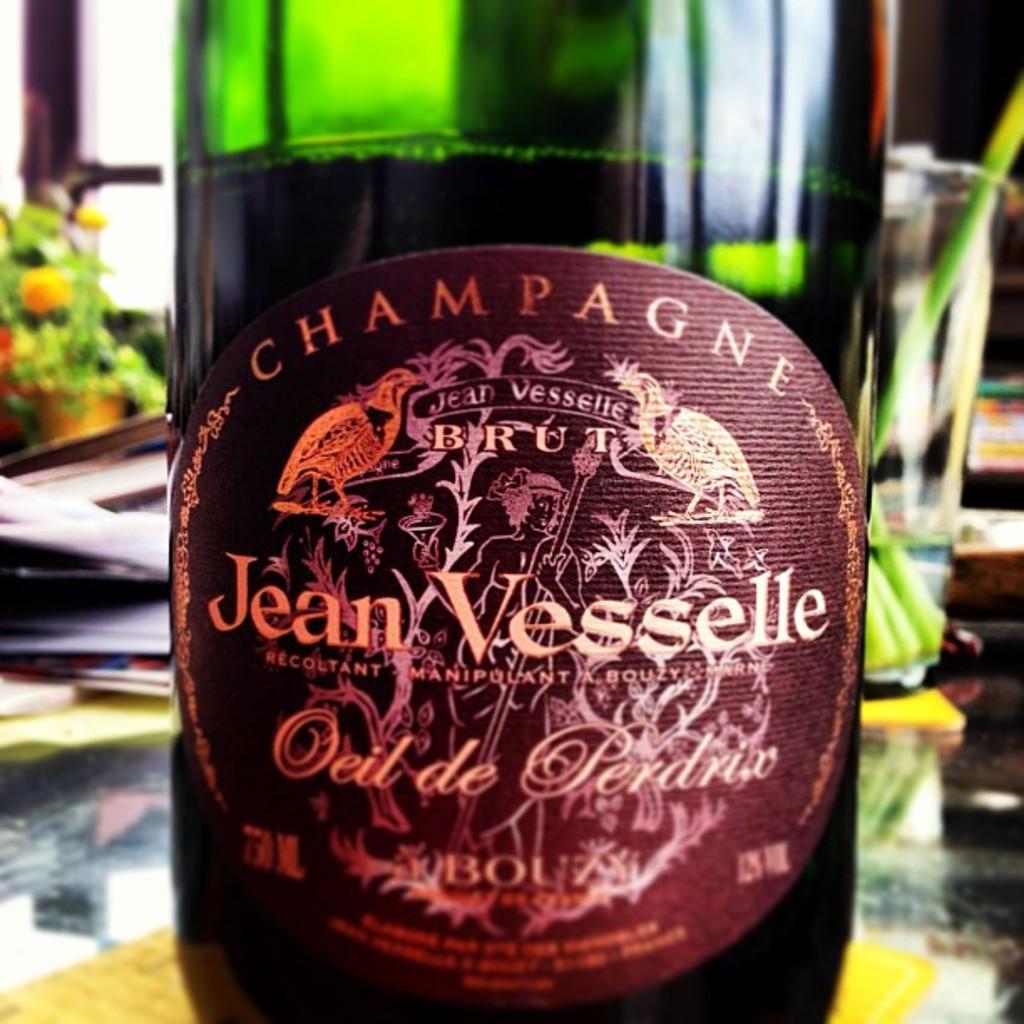What is the name of this beverage?
Your answer should be compact. Jean vesselle. 